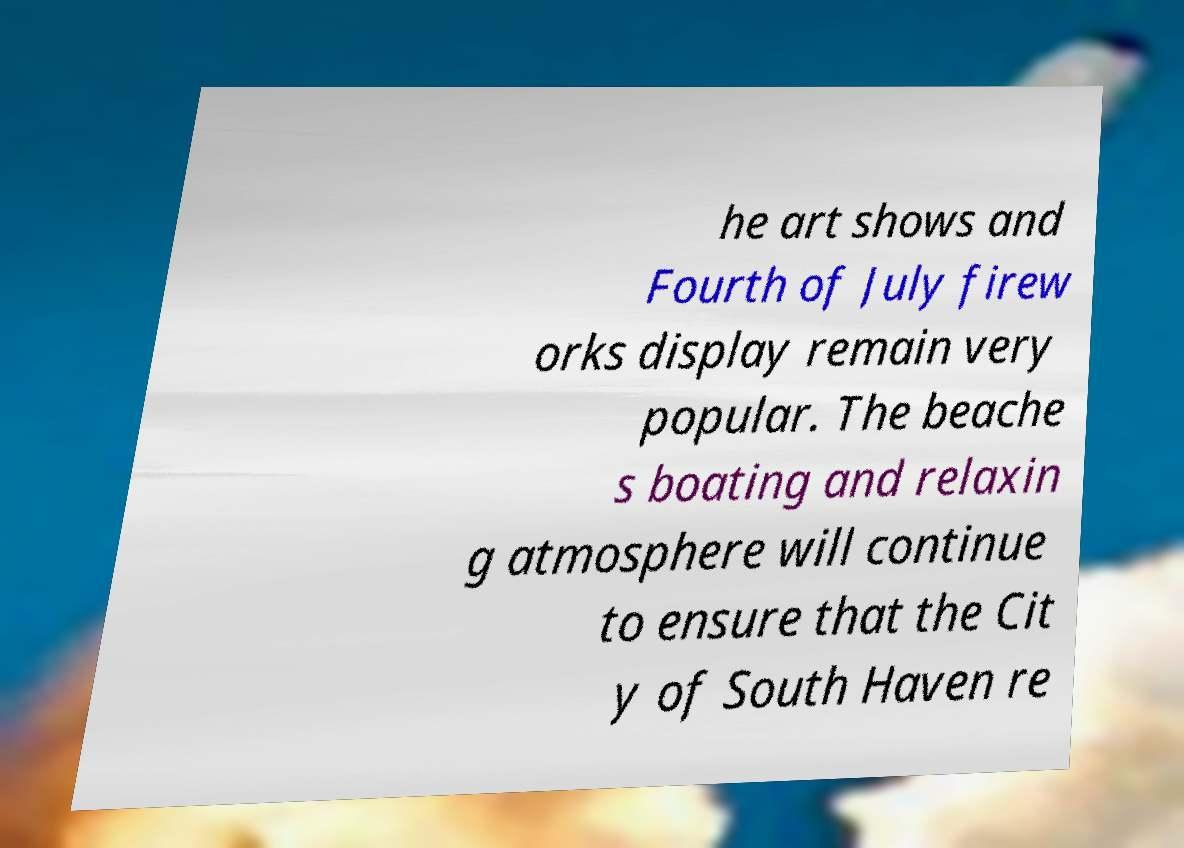Could you extract and type out the text from this image? he art shows and Fourth of July firew orks display remain very popular. The beache s boating and relaxin g atmosphere will continue to ensure that the Cit y of South Haven re 